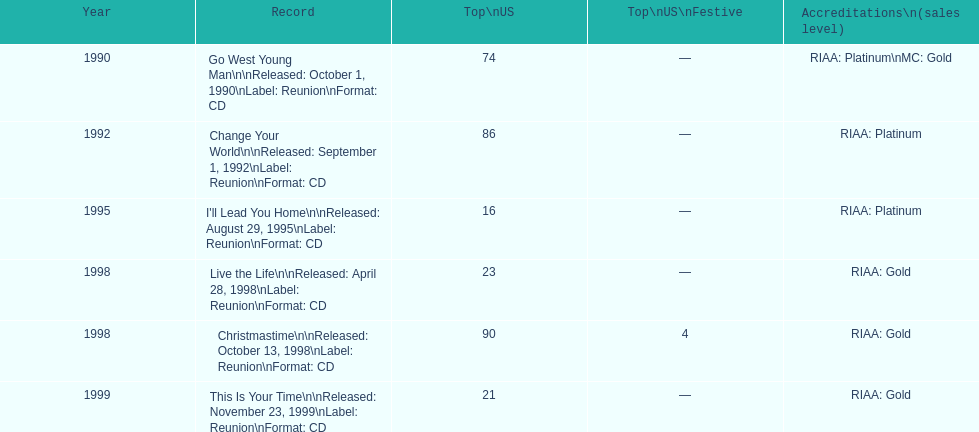In the us, which album had the smallest peak on the charts? I'll Lead You Home. 